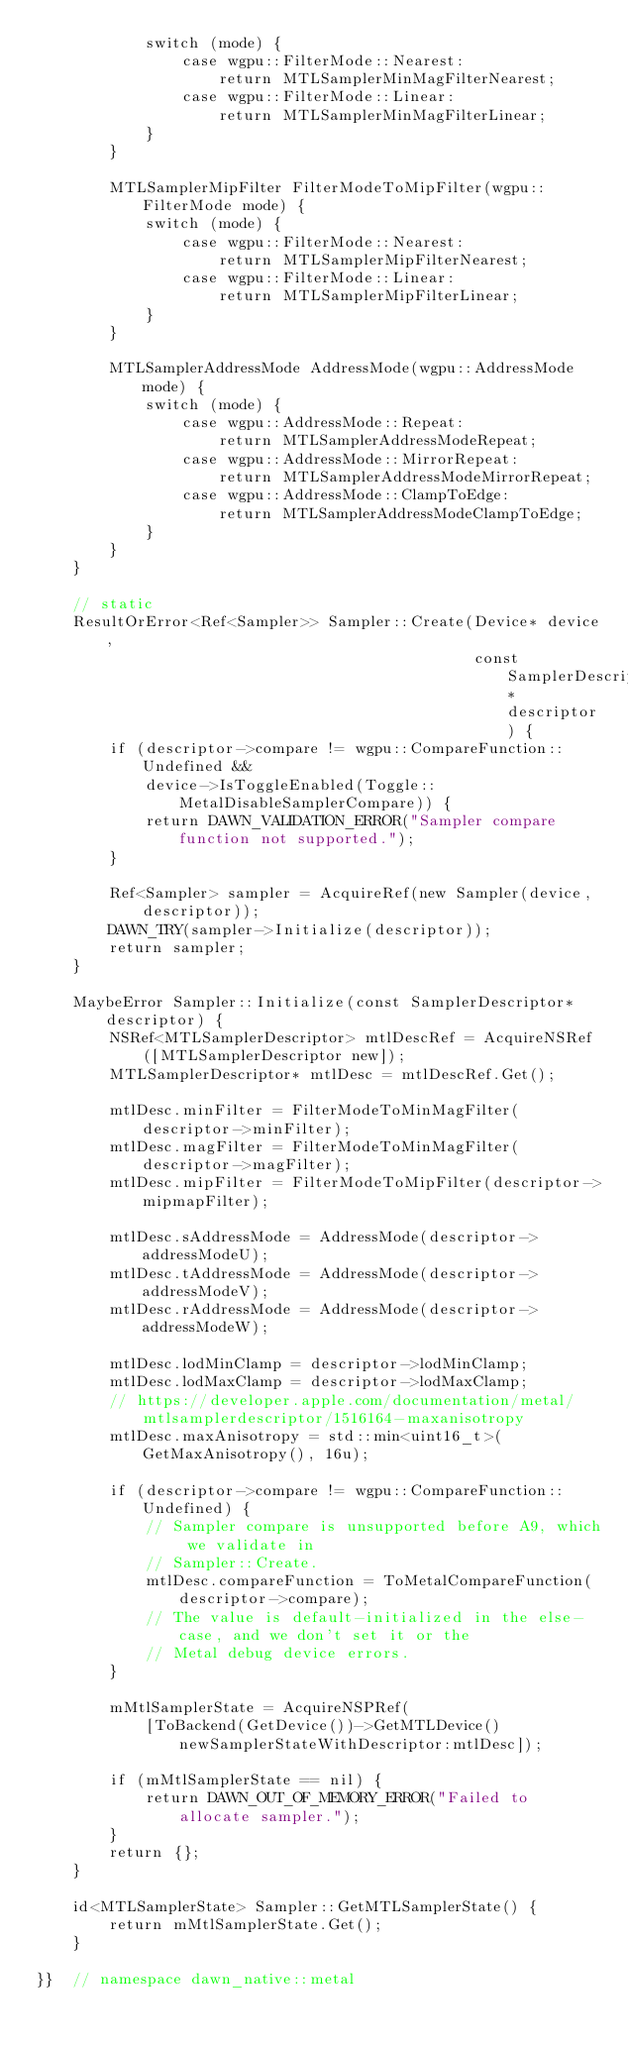Convert code to text. <code><loc_0><loc_0><loc_500><loc_500><_ObjectiveC_>            switch (mode) {
                case wgpu::FilterMode::Nearest:
                    return MTLSamplerMinMagFilterNearest;
                case wgpu::FilterMode::Linear:
                    return MTLSamplerMinMagFilterLinear;
            }
        }

        MTLSamplerMipFilter FilterModeToMipFilter(wgpu::FilterMode mode) {
            switch (mode) {
                case wgpu::FilterMode::Nearest:
                    return MTLSamplerMipFilterNearest;
                case wgpu::FilterMode::Linear:
                    return MTLSamplerMipFilterLinear;
            }
        }

        MTLSamplerAddressMode AddressMode(wgpu::AddressMode mode) {
            switch (mode) {
                case wgpu::AddressMode::Repeat:
                    return MTLSamplerAddressModeRepeat;
                case wgpu::AddressMode::MirrorRepeat:
                    return MTLSamplerAddressModeMirrorRepeat;
                case wgpu::AddressMode::ClampToEdge:
                    return MTLSamplerAddressModeClampToEdge;
            }
        }
    }

    // static
    ResultOrError<Ref<Sampler>> Sampler::Create(Device* device,
                                                const SamplerDescriptor* descriptor) {
        if (descriptor->compare != wgpu::CompareFunction::Undefined &&
            device->IsToggleEnabled(Toggle::MetalDisableSamplerCompare)) {
            return DAWN_VALIDATION_ERROR("Sampler compare function not supported.");
        }

        Ref<Sampler> sampler = AcquireRef(new Sampler(device, descriptor));
        DAWN_TRY(sampler->Initialize(descriptor));
        return sampler;
    }

    MaybeError Sampler::Initialize(const SamplerDescriptor* descriptor) {
        NSRef<MTLSamplerDescriptor> mtlDescRef = AcquireNSRef([MTLSamplerDescriptor new]);
        MTLSamplerDescriptor* mtlDesc = mtlDescRef.Get();

        mtlDesc.minFilter = FilterModeToMinMagFilter(descriptor->minFilter);
        mtlDesc.magFilter = FilterModeToMinMagFilter(descriptor->magFilter);
        mtlDesc.mipFilter = FilterModeToMipFilter(descriptor->mipmapFilter);

        mtlDesc.sAddressMode = AddressMode(descriptor->addressModeU);
        mtlDesc.tAddressMode = AddressMode(descriptor->addressModeV);
        mtlDesc.rAddressMode = AddressMode(descriptor->addressModeW);

        mtlDesc.lodMinClamp = descriptor->lodMinClamp;
        mtlDesc.lodMaxClamp = descriptor->lodMaxClamp;
        // https://developer.apple.com/documentation/metal/mtlsamplerdescriptor/1516164-maxanisotropy
        mtlDesc.maxAnisotropy = std::min<uint16_t>(GetMaxAnisotropy(), 16u);

        if (descriptor->compare != wgpu::CompareFunction::Undefined) {
            // Sampler compare is unsupported before A9, which we validate in
            // Sampler::Create.
            mtlDesc.compareFunction = ToMetalCompareFunction(descriptor->compare);
            // The value is default-initialized in the else-case, and we don't set it or the
            // Metal debug device errors.
        }

        mMtlSamplerState = AcquireNSPRef(
            [ToBackend(GetDevice())->GetMTLDevice() newSamplerStateWithDescriptor:mtlDesc]);

        if (mMtlSamplerState == nil) {
            return DAWN_OUT_OF_MEMORY_ERROR("Failed to allocate sampler.");
        }
        return {};
    }

    id<MTLSamplerState> Sampler::GetMTLSamplerState() {
        return mMtlSamplerState.Get();
    }

}}  // namespace dawn_native::metal
</code> 